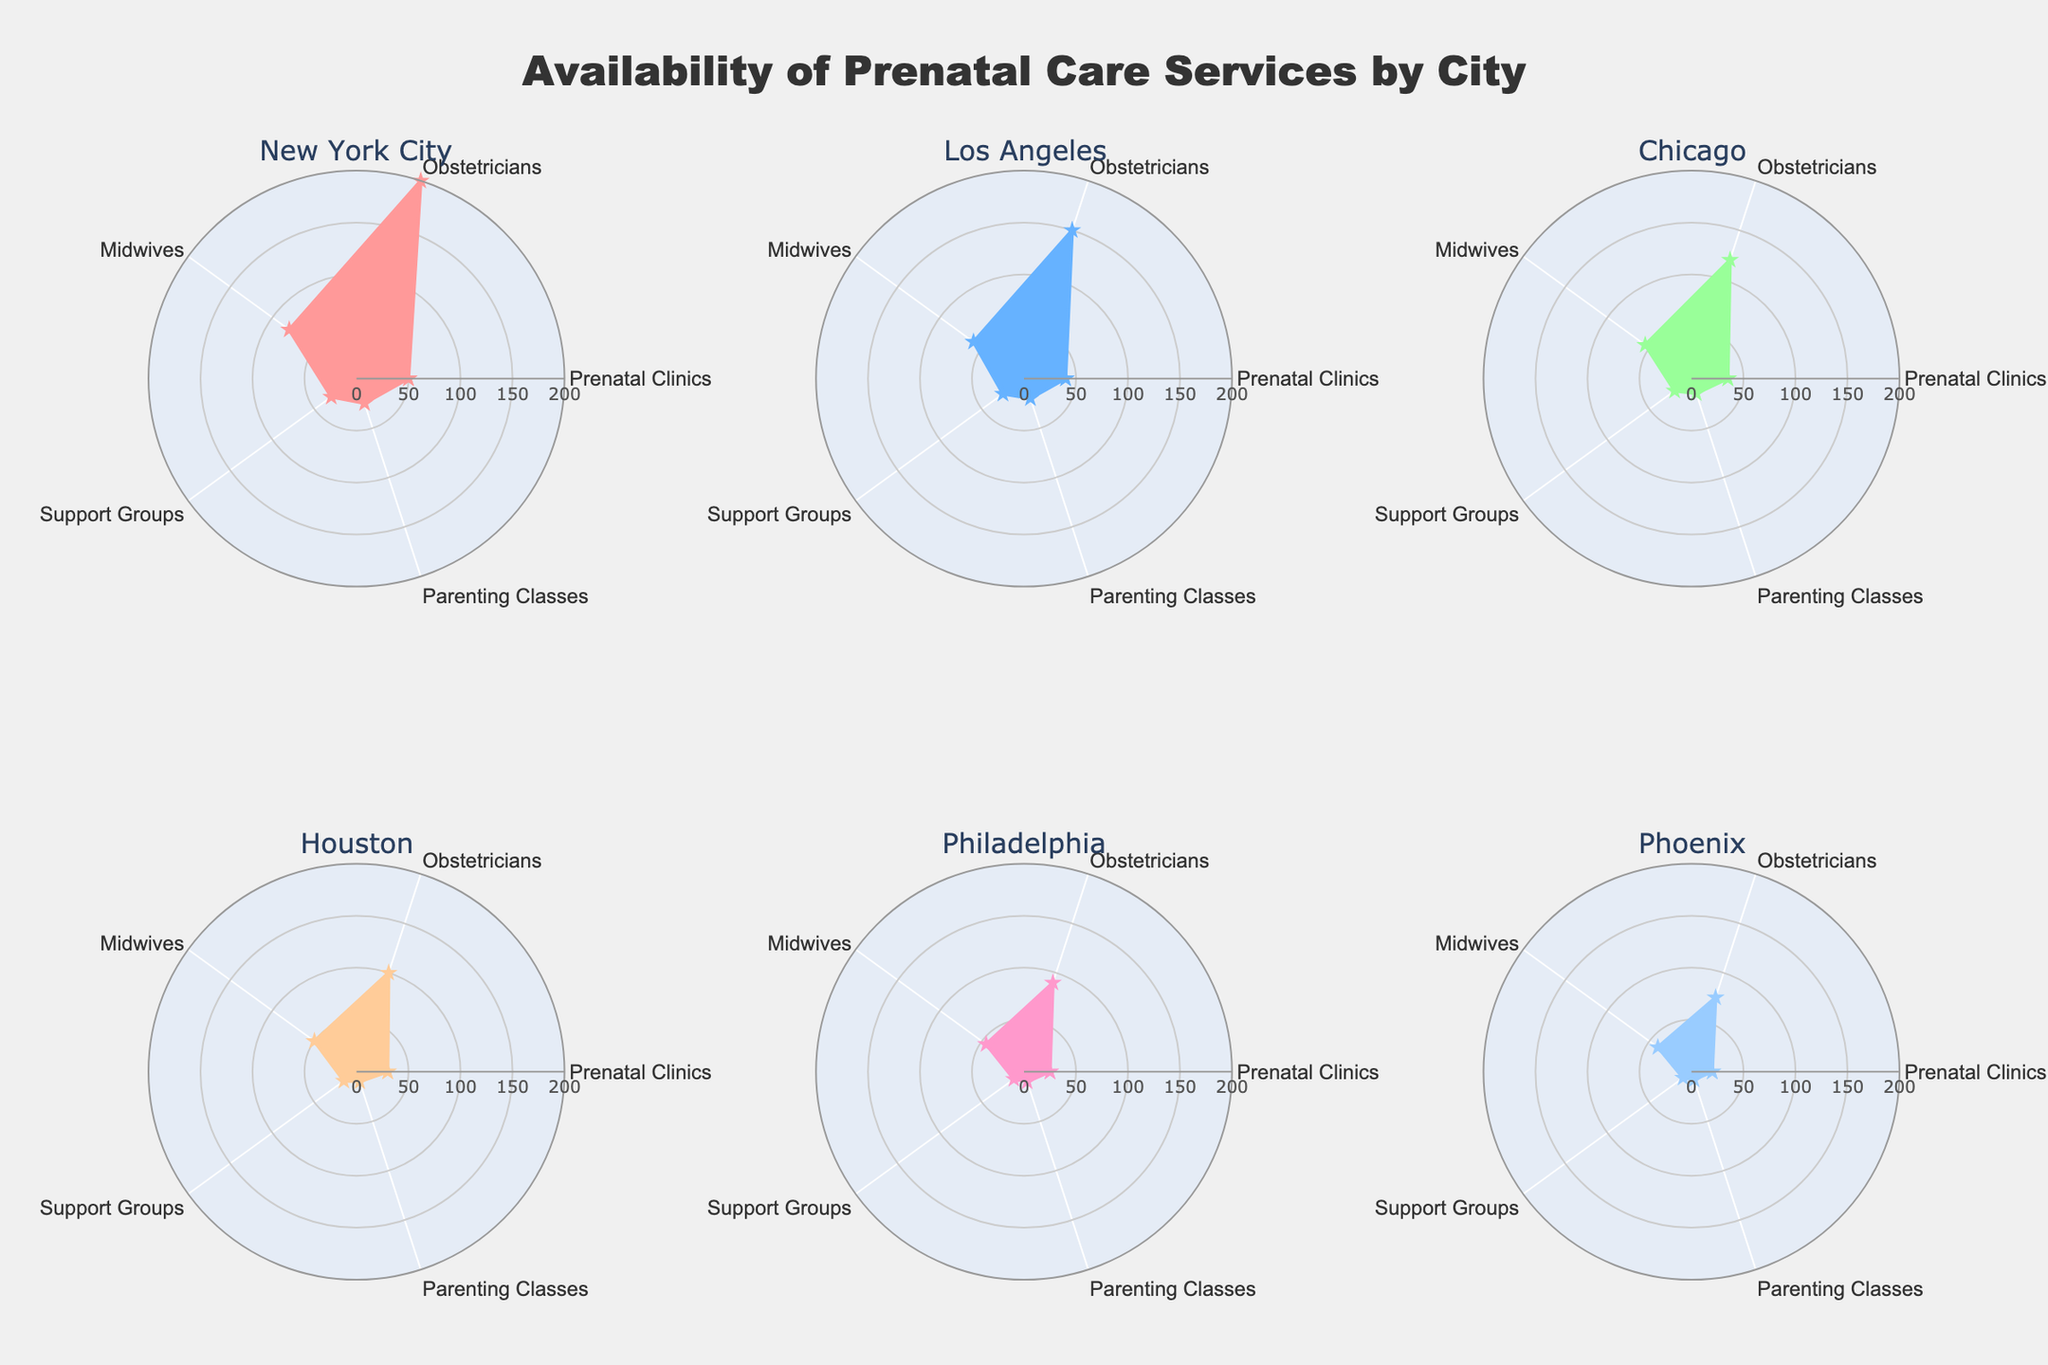What is the title of the figure? The title is usually displayed at the top of the figure and provides a summary of the information presented.
Answer: Availability of Prenatal Care Services by City Which city has the highest number of obstetricians? By examining each subplot, note the city with the longest line segment pointing to "Obstetricians."
Answer: New York City What is the range of the radial axis in the polar plots? The radial axis range is given in the figure settings, showing the scale of the values.
Answer: 0 to 200 How many cities are displayed in the figure? Count the number of subplot titles or individual circular plots.
Answer: 6 Which city has the smallest number of support groups? Find the shortest radial line segment leading to "Support Groups" among all the cities plotted.
Answer: San Jose Compare the number of midwives in New York City and Los Angeles. Which city has more? Look at the radial distance for the "Midwives" portion of the polar plot in both cities' subplots.
Answer: New York City What is the combined total of prenatal clinics in Chicago and Houston? Add the values for "Prenatal Clinics" in both Chicago's and Houston's subplots.
Answer: 65 Among the cities displayed, which one has the highest number of parenting classes? Identify the subplot with the longest radial segment for "Parenting Classes."
Answer: New York City Which city has more support groups: Philadelphia or San Diego? Compare the radial distances toward the "Support Groups" section of Philadelphia's and San Diego’s subplots.
Answer: San Diego Rank the six cities displayed from highest to lowest in terms of prenatal clinics. Check the radial lengths for "Prenatal Clinics" in each subplot and order them accordingly.
Answer: New York City, Los Angeles, Chicago, Dallas, Houston, San Diego 